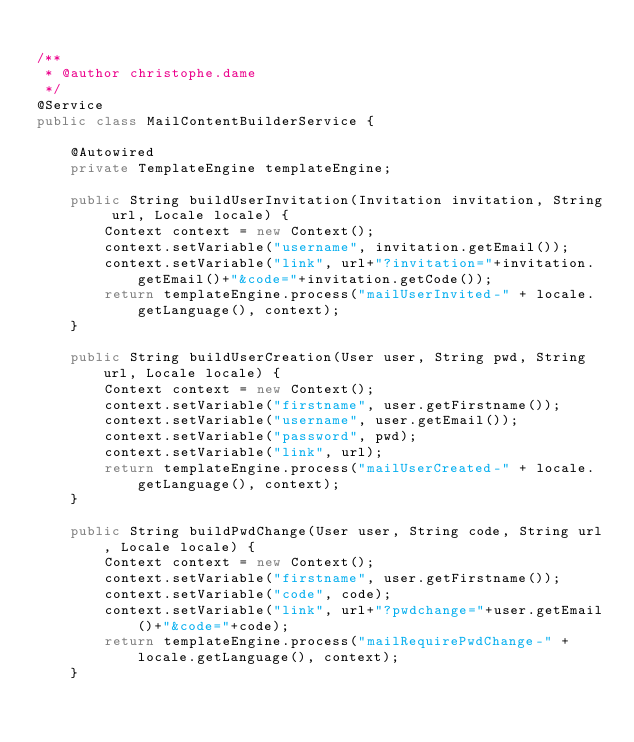Convert code to text. <code><loc_0><loc_0><loc_500><loc_500><_Java_>
/**
 * @author christophe.dame
 */
@Service
public class MailContentBuilderService {

    @Autowired
    private TemplateEngine templateEngine;

    public String buildUserInvitation(Invitation invitation, String url, Locale locale) {
        Context context = new Context();
        context.setVariable("username", invitation.getEmail());
        context.setVariable("link", url+"?invitation="+invitation.getEmail()+"&code="+invitation.getCode());
        return templateEngine.process("mailUserInvited-" + locale.getLanguage(), context);
    }

    public String buildUserCreation(User user, String pwd, String url, Locale locale) {
        Context context = new Context();
        context.setVariable("firstname", user.getFirstname());
        context.setVariable("username", user.getEmail());
        context.setVariable("password", pwd);
        context.setVariable("link", url);
        return templateEngine.process("mailUserCreated-" + locale.getLanguage(), context);
    }

    public String buildPwdChange(User user, String code, String url, Locale locale) {
        Context context = new Context();
        context.setVariable("firstname", user.getFirstname());
        context.setVariable("code", code);
        context.setVariable("link", url+"?pwdchange="+user.getEmail()+"&code="+code);
        return templateEngine.process("mailRequirePwdChange-" + locale.getLanguage(), context);
    }
</code> 